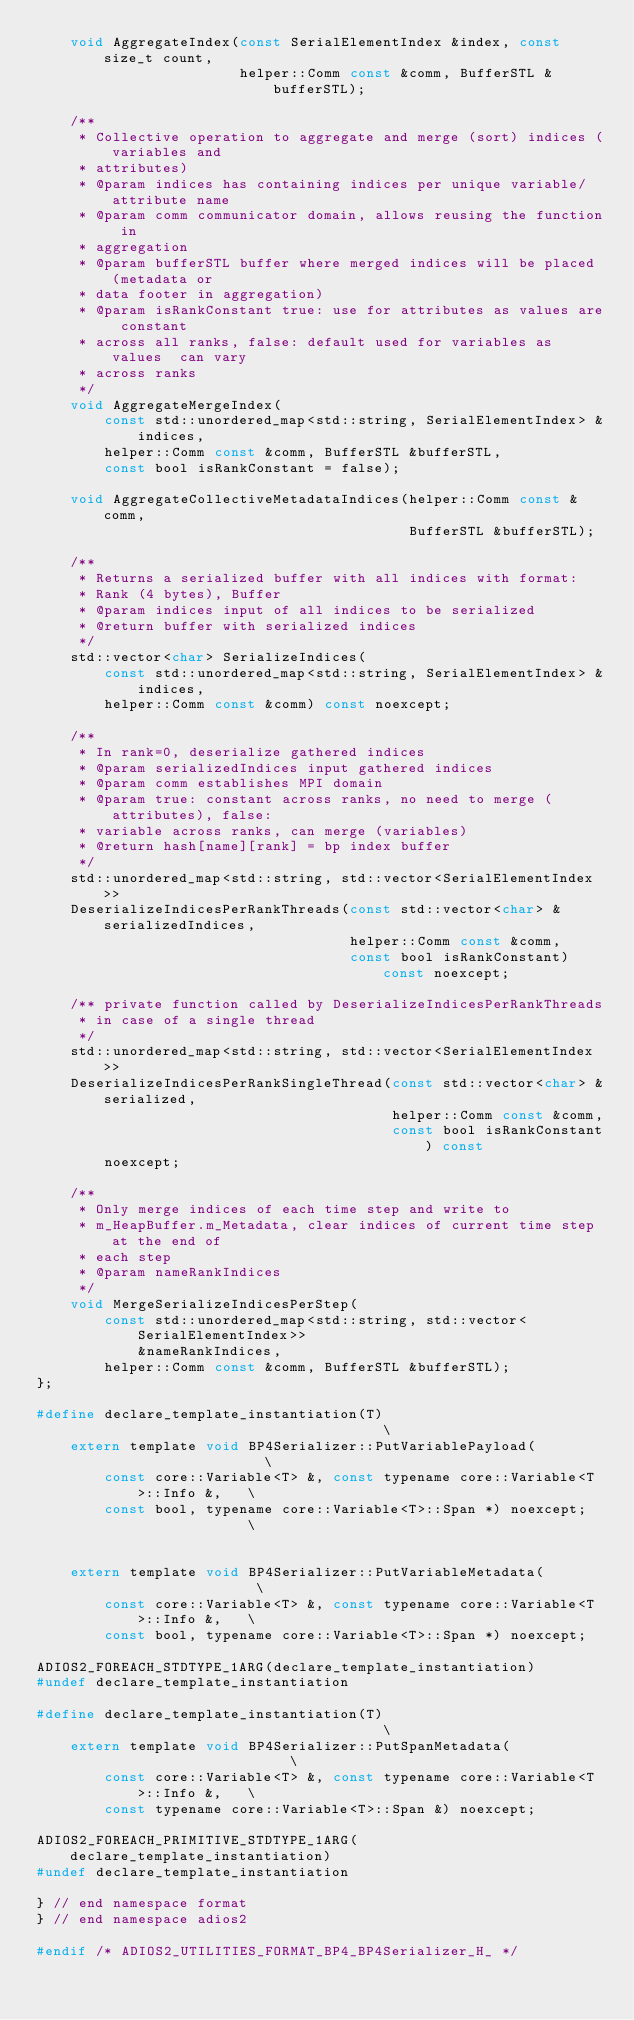<code> <loc_0><loc_0><loc_500><loc_500><_C_>    void AggregateIndex(const SerialElementIndex &index, const size_t count,
                        helper::Comm const &comm, BufferSTL &bufferSTL);

    /**
     * Collective operation to aggregate and merge (sort) indices (variables and
     * attributes)
     * @param indices has containing indices per unique variable/attribute name
     * @param comm communicator domain, allows reusing the function in
     * aggregation
     * @param bufferSTL buffer where merged indices will be placed (metadata or
     * data footer in aggregation)
     * @param isRankConstant true: use for attributes as values are constant
     * across all ranks, false: default used for variables as values  can vary
     * across ranks
     */
    void AggregateMergeIndex(
        const std::unordered_map<std::string, SerialElementIndex> &indices,
        helper::Comm const &comm, BufferSTL &bufferSTL,
        const bool isRankConstant = false);

    void AggregateCollectiveMetadataIndices(helper::Comm const &comm,
                                            BufferSTL &bufferSTL);

    /**
     * Returns a serialized buffer with all indices with format:
     * Rank (4 bytes), Buffer
     * @param indices input of all indices to be serialized
     * @return buffer with serialized indices
     */
    std::vector<char> SerializeIndices(
        const std::unordered_map<std::string, SerialElementIndex> &indices,
        helper::Comm const &comm) const noexcept;

    /**
     * In rank=0, deserialize gathered indices
     * @param serializedIndices input gathered indices
     * @param comm establishes MPI domain
     * @param true: constant across ranks, no need to merge (attributes), false:
     * variable across ranks, can merge (variables)
     * @return hash[name][rank] = bp index buffer
     */
    std::unordered_map<std::string, std::vector<SerialElementIndex>>
    DeserializeIndicesPerRankThreads(const std::vector<char> &serializedIndices,
                                     helper::Comm const &comm,
                                     const bool isRankConstant) const noexcept;

    /** private function called by DeserializeIndicesPerRankThreads
     * in case of a single thread
     */
    std::unordered_map<std::string, std::vector<SerialElementIndex>>
    DeserializeIndicesPerRankSingleThread(const std::vector<char> &serialized,
                                          helper::Comm const &comm,
                                          const bool isRankConstant) const
        noexcept;

    /**
     * Only merge indices of each time step and write to
     * m_HeapBuffer.m_Metadata, clear indices of current time step at the end of
     * each step
     * @param nameRankIndices
     */
    void MergeSerializeIndicesPerStep(
        const std::unordered_map<std::string, std::vector<SerialElementIndex>>
            &nameRankIndices,
        helper::Comm const &comm, BufferSTL &bufferSTL);
};

#define declare_template_instantiation(T)                                      \
    extern template void BP4Serializer::PutVariablePayload(                    \
        const core::Variable<T> &, const typename core::Variable<T>::Info &,   \
        const bool, typename core::Variable<T>::Span *) noexcept;              \
                                                                               \
    extern template void BP4Serializer::PutVariableMetadata(                   \
        const core::Variable<T> &, const typename core::Variable<T>::Info &,   \
        const bool, typename core::Variable<T>::Span *) noexcept;

ADIOS2_FOREACH_STDTYPE_1ARG(declare_template_instantiation)
#undef declare_template_instantiation

#define declare_template_instantiation(T)                                      \
    extern template void BP4Serializer::PutSpanMetadata(                       \
        const core::Variable<T> &, const typename core::Variable<T>::Info &,   \
        const typename core::Variable<T>::Span &) noexcept;

ADIOS2_FOREACH_PRIMITIVE_STDTYPE_1ARG(declare_template_instantiation)
#undef declare_template_instantiation

} // end namespace format
} // end namespace adios2

#endif /* ADIOS2_UTILITIES_FORMAT_BP4_BP4Serializer_H_ */
</code> 